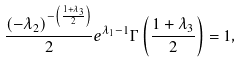<formula> <loc_0><loc_0><loc_500><loc_500>\frac { ( - \lambda _ { 2 } ) ^ { - \left ( \frac { 1 + \lambda _ { 3 } } { 2 } \right ) } } { 2 } { e ^ { \lambda _ { 1 } - 1 } } { \Gamma \left ( \frac { 1 + \lambda _ { 3 } } { 2 } \right ) } = 1 ,</formula> 